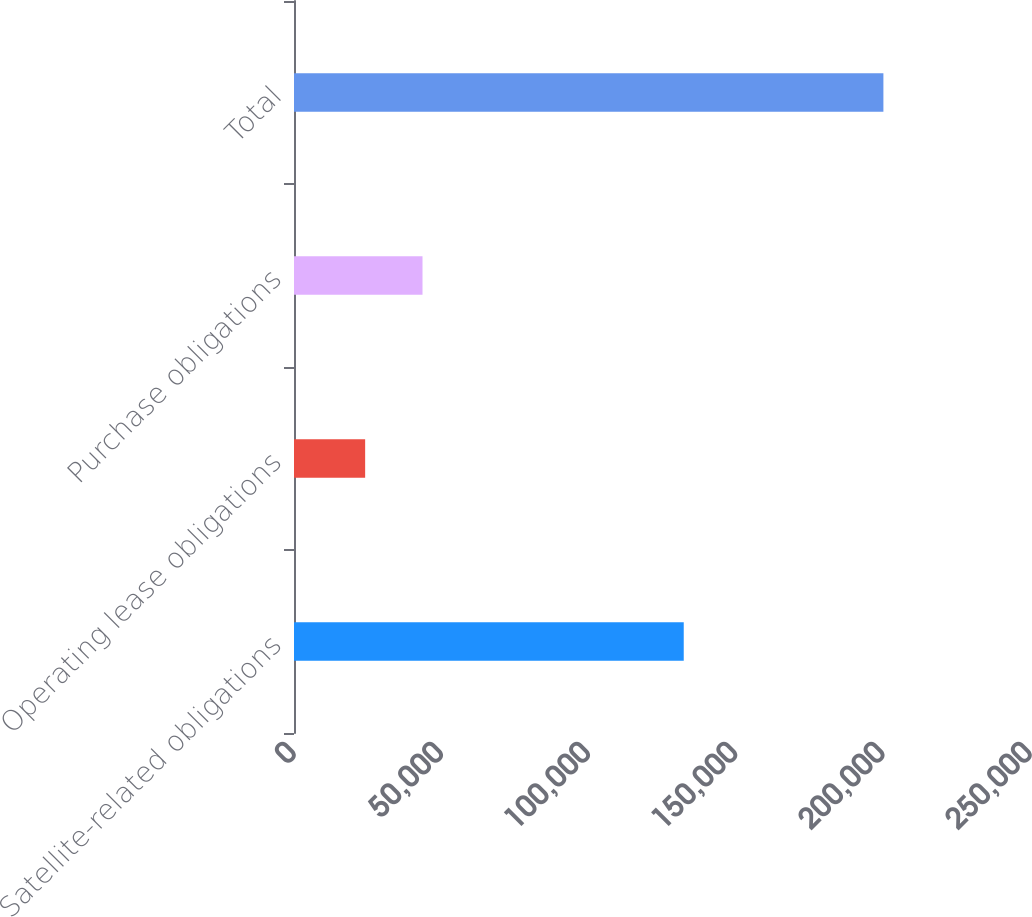Convert chart to OTSL. <chart><loc_0><loc_0><loc_500><loc_500><bar_chart><fcel>Satellite-related obligations<fcel>Operating lease obligations<fcel>Purchase obligations<fcel>Total<nl><fcel>132385<fcel>24168<fcel>43651<fcel>200204<nl></chart> 